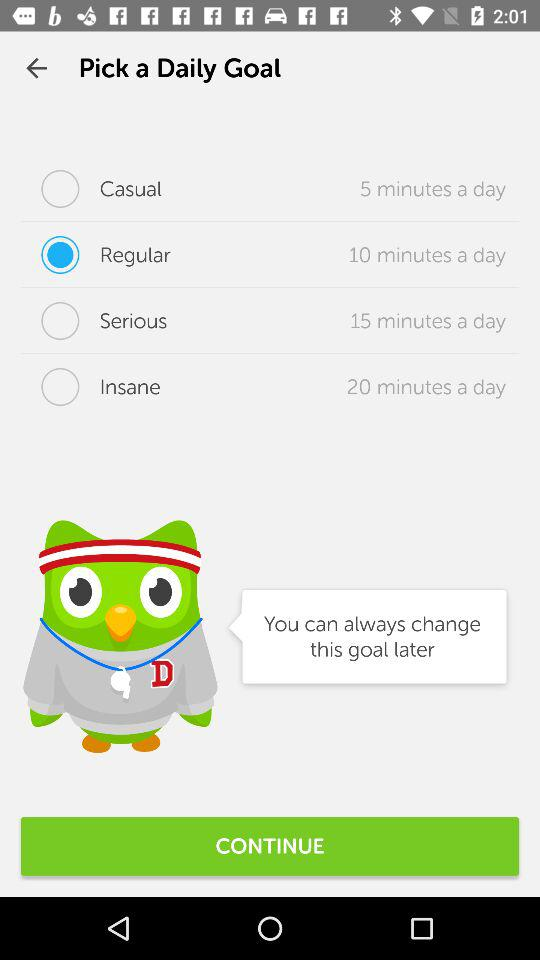How many more minutes of practice are required for the highest level of commitment than the lowest?
Answer the question using a single word or phrase. 15 